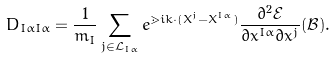<formula> <loc_0><loc_0><loc_500><loc_500>D _ { I \alpha I \alpha } = \frac { 1 } { m _ { I } } \sum _ { j \in \mathcal { L } _ { I \alpha } } e ^ { \mathbb { m } { i } k \cdot ( X ^ { j } - X ^ { I \alpha } ) } \frac { \partial ^ { 2 } \mathcal { E } } { \partial x ^ { I \alpha } \partial x ^ { j } } ( \mathcal { B } ) .</formula> 